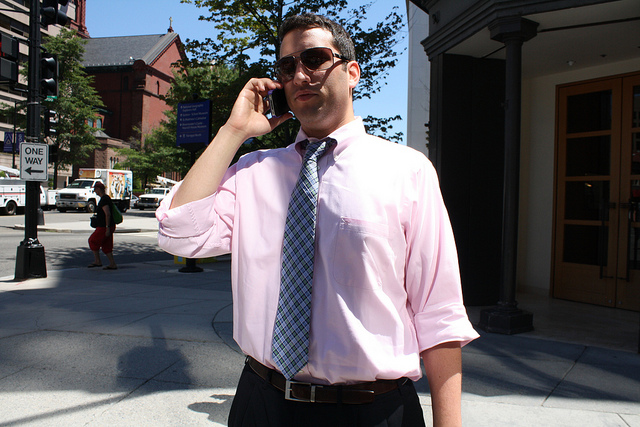<image>What color is the man's suitcase? It is not possible to determine the color of the man's suitcase. It is not shown in the image. What color is the man's suitcase? The man's suitcase color is not possible to determine as it is not shown in the image. 